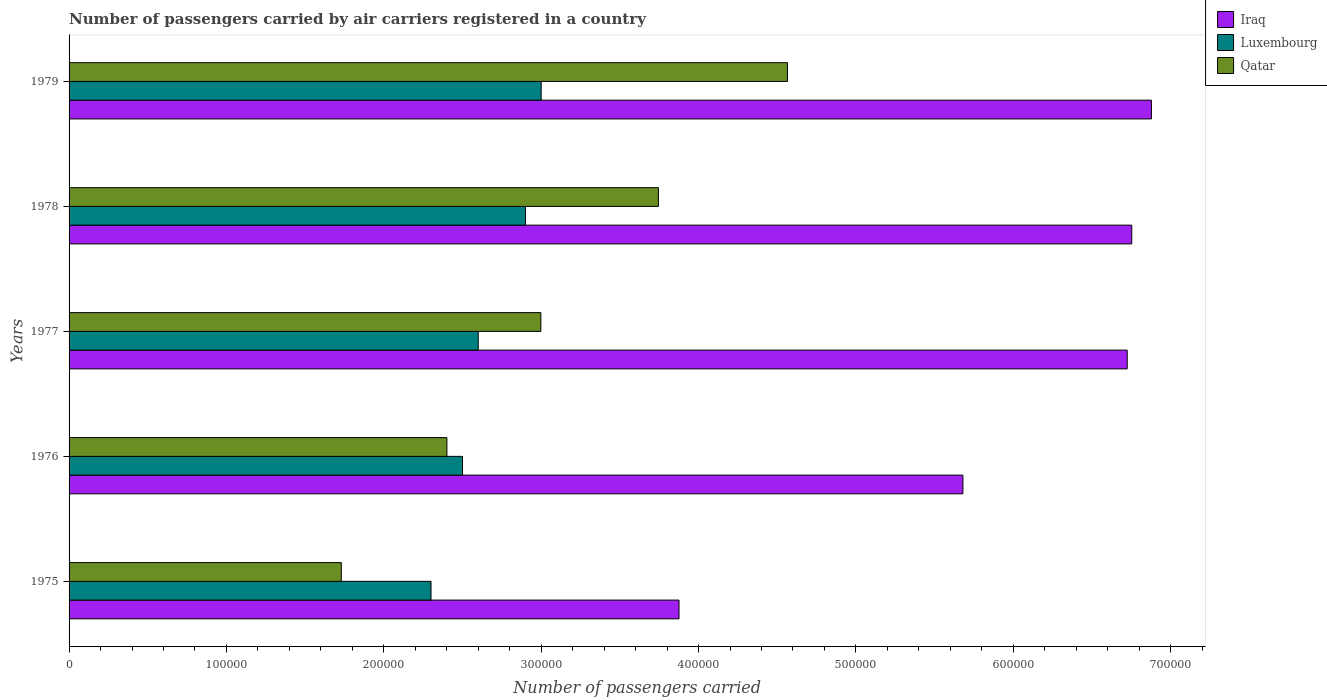How many different coloured bars are there?
Give a very brief answer. 3. How many groups of bars are there?
Offer a terse response. 5. Are the number of bars on each tick of the Y-axis equal?
Give a very brief answer. Yes. What is the label of the 4th group of bars from the top?
Ensure brevity in your answer.  1976. In how many cases, is the number of bars for a given year not equal to the number of legend labels?
Give a very brief answer. 0. What is the number of passengers carried by air carriers in Luxembourg in 1978?
Give a very brief answer. 2.90e+05. Across all years, what is the maximum number of passengers carried by air carriers in Luxembourg?
Your response must be concise. 3.00e+05. Across all years, what is the minimum number of passengers carried by air carriers in Iraq?
Offer a very short reply. 3.88e+05. In which year was the number of passengers carried by air carriers in Luxembourg maximum?
Ensure brevity in your answer.  1979. In which year was the number of passengers carried by air carriers in Qatar minimum?
Ensure brevity in your answer.  1975. What is the total number of passengers carried by air carriers in Iraq in the graph?
Make the answer very short. 2.99e+06. What is the difference between the number of passengers carried by air carriers in Iraq in 1976 and that in 1978?
Give a very brief answer. -1.07e+05. What is the difference between the number of passengers carried by air carriers in Qatar in 1979 and the number of passengers carried by air carriers in Luxembourg in 1977?
Your answer should be compact. 1.96e+05. What is the average number of passengers carried by air carriers in Qatar per year?
Provide a short and direct response. 3.09e+05. In the year 1978, what is the difference between the number of passengers carried by air carriers in Iraq and number of passengers carried by air carriers in Qatar?
Provide a short and direct response. 3.01e+05. In how many years, is the number of passengers carried by air carriers in Luxembourg greater than 640000 ?
Provide a short and direct response. 0. What is the ratio of the number of passengers carried by air carriers in Iraq in 1975 to that in 1979?
Make the answer very short. 0.56. Is the number of passengers carried by air carriers in Qatar in 1975 less than that in 1976?
Provide a succinct answer. Yes. What is the difference between the highest and the lowest number of passengers carried by air carriers in Iraq?
Offer a very short reply. 3.00e+05. In how many years, is the number of passengers carried by air carriers in Luxembourg greater than the average number of passengers carried by air carriers in Luxembourg taken over all years?
Your response must be concise. 2. Is the sum of the number of passengers carried by air carriers in Qatar in 1977 and 1979 greater than the maximum number of passengers carried by air carriers in Iraq across all years?
Keep it short and to the point. Yes. What does the 3rd bar from the top in 1978 represents?
Offer a terse response. Iraq. What does the 3rd bar from the bottom in 1975 represents?
Make the answer very short. Qatar. Is it the case that in every year, the sum of the number of passengers carried by air carriers in Qatar and number of passengers carried by air carriers in Iraq is greater than the number of passengers carried by air carriers in Luxembourg?
Your answer should be very brief. Yes. How many bars are there?
Your response must be concise. 15. Are all the bars in the graph horizontal?
Ensure brevity in your answer.  Yes. How many years are there in the graph?
Your answer should be compact. 5. Does the graph contain grids?
Give a very brief answer. No. How are the legend labels stacked?
Make the answer very short. Vertical. What is the title of the graph?
Your response must be concise. Number of passengers carried by air carriers registered in a country. Does "Bolivia" appear as one of the legend labels in the graph?
Give a very brief answer. No. What is the label or title of the X-axis?
Offer a very short reply. Number of passengers carried. What is the label or title of the Y-axis?
Your response must be concise. Years. What is the Number of passengers carried of Iraq in 1975?
Make the answer very short. 3.88e+05. What is the Number of passengers carried of Qatar in 1975?
Your answer should be compact. 1.73e+05. What is the Number of passengers carried in Iraq in 1976?
Your response must be concise. 5.68e+05. What is the Number of passengers carried of Luxembourg in 1976?
Make the answer very short. 2.50e+05. What is the Number of passengers carried in Qatar in 1976?
Your response must be concise. 2.40e+05. What is the Number of passengers carried in Iraq in 1977?
Keep it short and to the point. 6.72e+05. What is the Number of passengers carried in Luxembourg in 1977?
Ensure brevity in your answer.  2.60e+05. What is the Number of passengers carried in Qatar in 1977?
Keep it short and to the point. 3.00e+05. What is the Number of passengers carried of Iraq in 1978?
Your answer should be very brief. 6.75e+05. What is the Number of passengers carried in Luxembourg in 1978?
Provide a succinct answer. 2.90e+05. What is the Number of passengers carried of Qatar in 1978?
Offer a terse response. 3.74e+05. What is the Number of passengers carried in Iraq in 1979?
Keep it short and to the point. 6.88e+05. What is the Number of passengers carried of Luxembourg in 1979?
Offer a terse response. 3.00e+05. What is the Number of passengers carried in Qatar in 1979?
Ensure brevity in your answer.  4.56e+05. Across all years, what is the maximum Number of passengers carried of Iraq?
Your answer should be compact. 6.88e+05. Across all years, what is the maximum Number of passengers carried in Luxembourg?
Provide a short and direct response. 3.00e+05. Across all years, what is the maximum Number of passengers carried of Qatar?
Offer a terse response. 4.56e+05. Across all years, what is the minimum Number of passengers carried of Iraq?
Ensure brevity in your answer.  3.88e+05. Across all years, what is the minimum Number of passengers carried of Luxembourg?
Ensure brevity in your answer.  2.30e+05. Across all years, what is the minimum Number of passengers carried in Qatar?
Ensure brevity in your answer.  1.73e+05. What is the total Number of passengers carried of Iraq in the graph?
Make the answer very short. 2.99e+06. What is the total Number of passengers carried of Luxembourg in the graph?
Make the answer very short. 1.33e+06. What is the total Number of passengers carried of Qatar in the graph?
Offer a very short reply. 1.54e+06. What is the difference between the Number of passengers carried in Iraq in 1975 and that in 1976?
Offer a very short reply. -1.80e+05. What is the difference between the Number of passengers carried of Qatar in 1975 and that in 1976?
Ensure brevity in your answer.  -6.71e+04. What is the difference between the Number of passengers carried in Iraq in 1975 and that in 1977?
Your answer should be compact. -2.85e+05. What is the difference between the Number of passengers carried of Qatar in 1975 and that in 1977?
Your answer should be very brief. -1.27e+05. What is the difference between the Number of passengers carried of Iraq in 1975 and that in 1978?
Your answer should be compact. -2.88e+05. What is the difference between the Number of passengers carried of Luxembourg in 1975 and that in 1978?
Your answer should be very brief. -6.00e+04. What is the difference between the Number of passengers carried of Qatar in 1975 and that in 1978?
Offer a terse response. -2.02e+05. What is the difference between the Number of passengers carried in Iraq in 1975 and that in 1979?
Provide a succinct answer. -3.00e+05. What is the difference between the Number of passengers carried of Luxembourg in 1975 and that in 1979?
Keep it short and to the point. -7.00e+04. What is the difference between the Number of passengers carried in Qatar in 1975 and that in 1979?
Offer a terse response. -2.84e+05. What is the difference between the Number of passengers carried of Iraq in 1976 and that in 1977?
Your answer should be compact. -1.04e+05. What is the difference between the Number of passengers carried of Luxembourg in 1976 and that in 1977?
Provide a succinct answer. -10000. What is the difference between the Number of passengers carried in Qatar in 1976 and that in 1977?
Offer a terse response. -5.97e+04. What is the difference between the Number of passengers carried of Iraq in 1976 and that in 1978?
Provide a short and direct response. -1.07e+05. What is the difference between the Number of passengers carried in Qatar in 1976 and that in 1978?
Your answer should be very brief. -1.34e+05. What is the difference between the Number of passengers carried in Iraq in 1976 and that in 1979?
Offer a terse response. -1.20e+05. What is the difference between the Number of passengers carried in Luxembourg in 1976 and that in 1979?
Your answer should be very brief. -5.00e+04. What is the difference between the Number of passengers carried in Qatar in 1976 and that in 1979?
Offer a very short reply. -2.16e+05. What is the difference between the Number of passengers carried of Iraq in 1977 and that in 1978?
Give a very brief answer. -2900. What is the difference between the Number of passengers carried of Luxembourg in 1977 and that in 1978?
Offer a terse response. -3.00e+04. What is the difference between the Number of passengers carried of Qatar in 1977 and that in 1978?
Offer a very short reply. -7.47e+04. What is the difference between the Number of passengers carried in Iraq in 1977 and that in 1979?
Keep it short and to the point. -1.54e+04. What is the difference between the Number of passengers carried in Luxembourg in 1977 and that in 1979?
Your response must be concise. -4.00e+04. What is the difference between the Number of passengers carried in Qatar in 1977 and that in 1979?
Make the answer very short. -1.57e+05. What is the difference between the Number of passengers carried of Iraq in 1978 and that in 1979?
Keep it short and to the point. -1.25e+04. What is the difference between the Number of passengers carried of Qatar in 1978 and that in 1979?
Provide a short and direct response. -8.20e+04. What is the difference between the Number of passengers carried in Iraq in 1975 and the Number of passengers carried in Luxembourg in 1976?
Offer a very short reply. 1.38e+05. What is the difference between the Number of passengers carried in Iraq in 1975 and the Number of passengers carried in Qatar in 1976?
Provide a succinct answer. 1.48e+05. What is the difference between the Number of passengers carried of Luxembourg in 1975 and the Number of passengers carried of Qatar in 1976?
Offer a very short reply. -1.01e+04. What is the difference between the Number of passengers carried in Iraq in 1975 and the Number of passengers carried in Luxembourg in 1977?
Give a very brief answer. 1.28e+05. What is the difference between the Number of passengers carried of Iraq in 1975 and the Number of passengers carried of Qatar in 1977?
Your answer should be very brief. 8.78e+04. What is the difference between the Number of passengers carried in Luxembourg in 1975 and the Number of passengers carried in Qatar in 1977?
Offer a very short reply. -6.98e+04. What is the difference between the Number of passengers carried of Iraq in 1975 and the Number of passengers carried of Luxembourg in 1978?
Provide a short and direct response. 9.76e+04. What is the difference between the Number of passengers carried in Iraq in 1975 and the Number of passengers carried in Qatar in 1978?
Offer a terse response. 1.31e+04. What is the difference between the Number of passengers carried in Luxembourg in 1975 and the Number of passengers carried in Qatar in 1978?
Give a very brief answer. -1.44e+05. What is the difference between the Number of passengers carried of Iraq in 1975 and the Number of passengers carried of Luxembourg in 1979?
Give a very brief answer. 8.76e+04. What is the difference between the Number of passengers carried in Iraq in 1975 and the Number of passengers carried in Qatar in 1979?
Your answer should be compact. -6.89e+04. What is the difference between the Number of passengers carried of Luxembourg in 1975 and the Number of passengers carried of Qatar in 1979?
Your answer should be compact. -2.26e+05. What is the difference between the Number of passengers carried in Iraq in 1976 and the Number of passengers carried in Luxembourg in 1977?
Your answer should be compact. 3.08e+05. What is the difference between the Number of passengers carried of Iraq in 1976 and the Number of passengers carried of Qatar in 1977?
Offer a very short reply. 2.68e+05. What is the difference between the Number of passengers carried of Luxembourg in 1976 and the Number of passengers carried of Qatar in 1977?
Your answer should be very brief. -4.98e+04. What is the difference between the Number of passengers carried of Iraq in 1976 and the Number of passengers carried of Luxembourg in 1978?
Offer a terse response. 2.78e+05. What is the difference between the Number of passengers carried of Iraq in 1976 and the Number of passengers carried of Qatar in 1978?
Provide a succinct answer. 1.94e+05. What is the difference between the Number of passengers carried in Luxembourg in 1976 and the Number of passengers carried in Qatar in 1978?
Your response must be concise. -1.24e+05. What is the difference between the Number of passengers carried of Iraq in 1976 and the Number of passengers carried of Luxembourg in 1979?
Your answer should be compact. 2.68e+05. What is the difference between the Number of passengers carried in Iraq in 1976 and the Number of passengers carried in Qatar in 1979?
Your response must be concise. 1.12e+05. What is the difference between the Number of passengers carried in Luxembourg in 1976 and the Number of passengers carried in Qatar in 1979?
Provide a succinct answer. -2.06e+05. What is the difference between the Number of passengers carried in Iraq in 1977 and the Number of passengers carried in Luxembourg in 1978?
Offer a very short reply. 3.82e+05. What is the difference between the Number of passengers carried in Iraq in 1977 and the Number of passengers carried in Qatar in 1978?
Your answer should be compact. 2.98e+05. What is the difference between the Number of passengers carried in Luxembourg in 1977 and the Number of passengers carried in Qatar in 1978?
Offer a very short reply. -1.14e+05. What is the difference between the Number of passengers carried of Iraq in 1977 and the Number of passengers carried of Luxembourg in 1979?
Keep it short and to the point. 3.72e+05. What is the difference between the Number of passengers carried of Iraq in 1977 and the Number of passengers carried of Qatar in 1979?
Provide a succinct answer. 2.16e+05. What is the difference between the Number of passengers carried of Luxembourg in 1977 and the Number of passengers carried of Qatar in 1979?
Give a very brief answer. -1.96e+05. What is the difference between the Number of passengers carried of Iraq in 1978 and the Number of passengers carried of Luxembourg in 1979?
Offer a very short reply. 3.75e+05. What is the difference between the Number of passengers carried in Iraq in 1978 and the Number of passengers carried in Qatar in 1979?
Provide a short and direct response. 2.19e+05. What is the difference between the Number of passengers carried in Luxembourg in 1978 and the Number of passengers carried in Qatar in 1979?
Offer a very short reply. -1.66e+05. What is the average Number of passengers carried of Iraq per year?
Your answer should be compact. 5.98e+05. What is the average Number of passengers carried in Luxembourg per year?
Provide a succinct answer. 2.66e+05. What is the average Number of passengers carried in Qatar per year?
Your response must be concise. 3.09e+05. In the year 1975, what is the difference between the Number of passengers carried in Iraq and Number of passengers carried in Luxembourg?
Give a very brief answer. 1.58e+05. In the year 1975, what is the difference between the Number of passengers carried in Iraq and Number of passengers carried in Qatar?
Your response must be concise. 2.15e+05. In the year 1975, what is the difference between the Number of passengers carried of Luxembourg and Number of passengers carried of Qatar?
Provide a short and direct response. 5.70e+04. In the year 1976, what is the difference between the Number of passengers carried in Iraq and Number of passengers carried in Luxembourg?
Your answer should be very brief. 3.18e+05. In the year 1976, what is the difference between the Number of passengers carried of Iraq and Number of passengers carried of Qatar?
Your answer should be compact. 3.28e+05. In the year 1976, what is the difference between the Number of passengers carried of Luxembourg and Number of passengers carried of Qatar?
Your answer should be compact. 9900. In the year 1977, what is the difference between the Number of passengers carried of Iraq and Number of passengers carried of Luxembourg?
Provide a short and direct response. 4.12e+05. In the year 1977, what is the difference between the Number of passengers carried in Iraq and Number of passengers carried in Qatar?
Provide a short and direct response. 3.73e+05. In the year 1977, what is the difference between the Number of passengers carried in Luxembourg and Number of passengers carried in Qatar?
Your answer should be compact. -3.98e+04. In the year 1978, what is the difference between the Number of passengers carried of Iraq and Number of passengers carried of Luxembourg?
Give a very brief answer. 3.85e+05. In the year 1978, what is the difference between the Number of passengers carried in Iraq and Number of passengers carried in Qatar?
Give a very brief answer. 3.01e+05. In the year 1978, what is the difference between the Number of passengers carried in Luxembourg and Number of passengers carried in Qatar?
Your response must be concise. -8.45e+04. In the year 1979, what is the difference between the Number of passengers carried of Iraq and Number of passengers carried of Luxembourg?
Ensure brevity in your answer.  3.88e+05. In the year 1979, what is the difference between the Number of passengers carried of Iraq and Number of passengers carried of Qatar?
Offer a terse response. 2.31e+05. In the year 1979, what is the difference between the Number of passengers carried of Luxembourg and Number of passengers carried of Qatar?
Make the answer very short. -1.56e+05. What is the ratio of the Number of passengers carried in Iraq in 1975 to that in 1976?
Ensure brevity in your answer.  0.68. What is the ratio of the Number of passengers carried of Qatar in 1975 to that in 1976?
Your answer should be compact. 0.72. What is the ratio of the Number of passengers carried of Iraq in 1975 to that in 1977?
Offer a terse response. 0.58. What is the ratio of the Number of passengers carried in Luxembourg in 1975 to that in 1977?
Keep it short and to the point. 0.88. What is the ratio of the Number of passengers carried of Qatar in 1975 to that in 1977?
Your answer should be compact. 0.58. What is the ratio of the Number of passengers carried of Iraq in 1975 to that in 1978?
Give a very brief answer. 0.57. What is the ratio of the Number of passengers carried of Luxembourg in 1975 to that in 1978?
Keep it short and to the point. 0.79. What is the ratio of the Number of passengers carried of Qatar in 1975 to that in 1978?
Provide a short and direct response. 0.46. What is the ratio of the Number of passengers carried of Iraq in 1975 to that in 1979?
Keep it short and to the point. 0.56. What is the ratio of the Number of passengers carried in Luxembourg in 1975 to that in 1979?
Ensure brevity in your answer.  0.77. What is the ratio of the Number of passengers carried of Qatar in 1975 to that in 1979?
Give a very brief answer. 0.38. What is the ratio of the Number of passengers carried of Iraq in 1976 to that in 1977?
Ensure brevity in your answer.  0.84. What is the ratio of the Number of passengers carried of Luxembourg in 1976 to that in 1977?
Your response must be concise. 0.96. What is the ratio of the Number of passengers carried in Qatar in 1976 to that in 1977?
Offer a very short reply. 0.8. What is the ratio of the Number of passengers carried in Iraq in 1976 to that in 1978?
Ensure brevity in your answer.  0.84. What is the ratio of the Number of passengers carried of Luxembourg in 1976 to that in 1978?
Your answer should be compact. 0.86. What is the ratio of the Number of passengers carried in Qatar in 1976 to that in 1978?
Offer a terse response. 0.64. What is the ratio of the Number of passengers carried in Iraq in 1976 to that in 1979?
Offer a terse response. 0.83. What is the ratio of the Number of passengers carried in Qatar in 1976 to that in 1979?
Your answer should be very brief. 0.53. What is the ratio of the Number of passengers carried in Luxembourg in 1977 to that in 1978?
Make the answer very short. 0.9. What is the ratio of the Number of passengers carried in Qatar in 1977 to that in 1978?
Provide a succinct answer. 0.8. What is the ratio of the Number of passengers carried in Iraq in 1977 to that in 1979?
Offer a very short reply. 0.98. What is the ratio of the Number of passengers carried in Luxembourg in 1977 to that in 1979?
Provide a short and direct response. 0.87. What is the ratio of the Number of passengers carried in Qatar in 1977 to that in 1979?
Give a very brief answer. 0.66. What is the ratio of the Number of passengers carried in Iraq in 1978 to that in 1979?
Your response must be concise. 0.98. What is the ratio of the Number of passengers carried of Luxembourg in 1978 to that in 1979?
Your answer should be very brief. 0.97. What is the ratio of the Number of passengers carried in Qatar in 1978 to that in 1979?
Give a very brief answer. 0.82. What is the difference between the highest and the second highest Number of passengers carried in Iraq?
Make the answer very short. 1.25e+04. What is the difference between the highest and the second highest Number of passengers carried of Qatar?
Offer a terse response. 8.20e+04. What is the difference between the highest and the lowest Number of passengers carried of Iraq?
Ensure brevity in your answer.  3.00e+05. What is the difference between the highest and the lowest Number of passengers carried of Qatar?
Your response must be concise. 2.84e+05. 